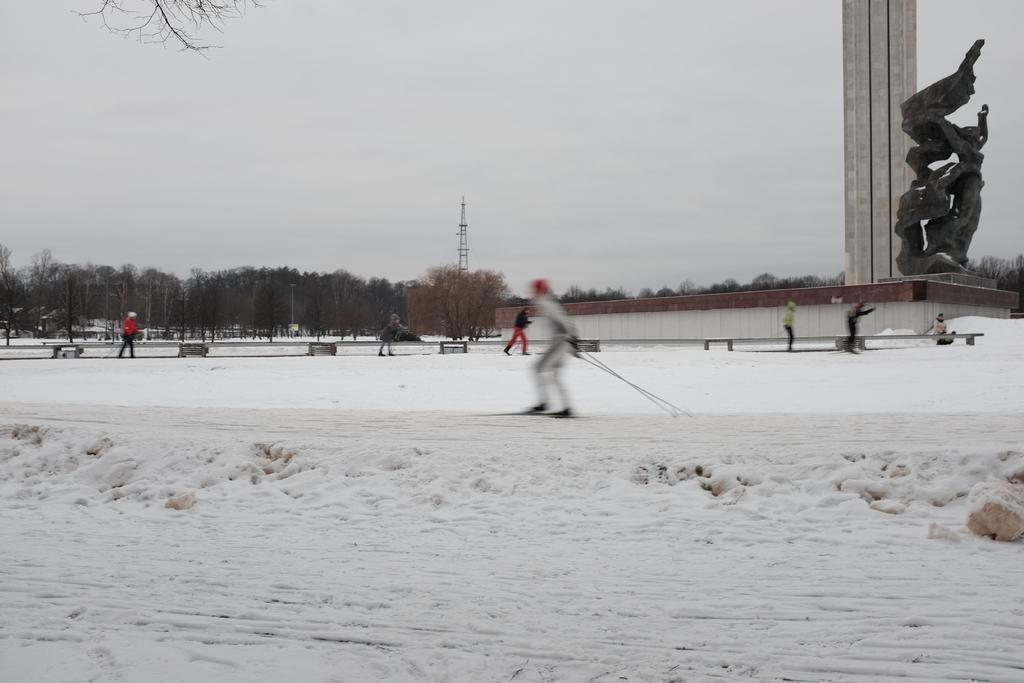Describe this image in one or two sentences. There is a person skiing on the snow. Here we can see trees, poles, towers, sculpture, and few persons. In the background there is sky. 